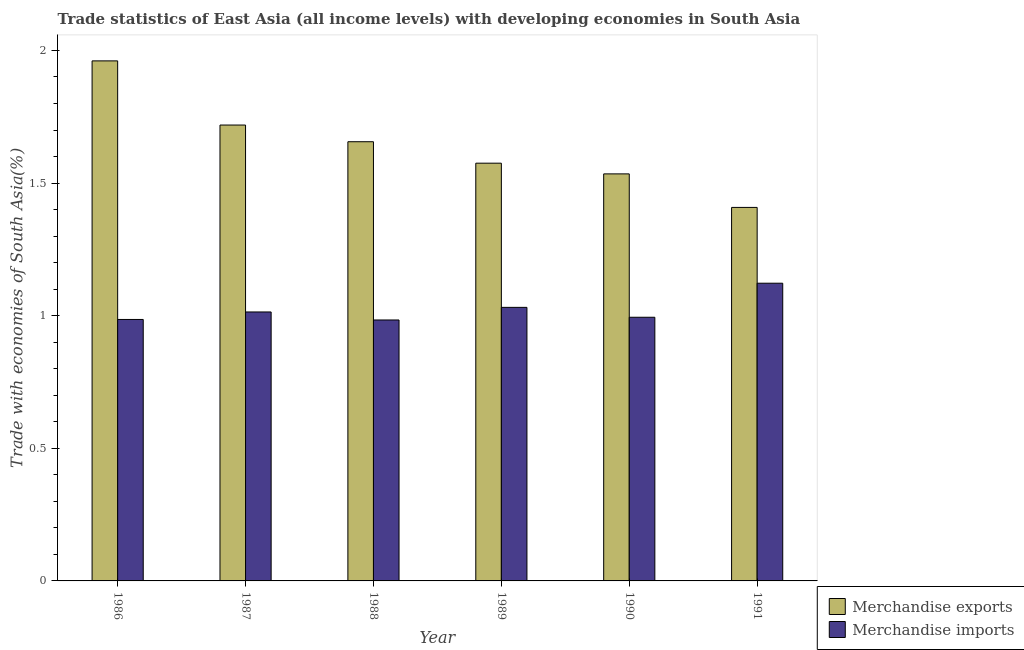How many different coloured bars are there?
Your response must be concise. 2. How many bars are there on the 2nd tick from the left?
Offer a terse response. 2. In how many cases, is the number of bars for a given year not equal to the number of legend labels?
Make the answer very short. 0. What is the merchandise imports in 1988?
Provide a short and direct response. 0.98. Across all years, what is the maximum merchandise imports?
Your answer should be compact. 1.12. Across all years, what is the minimum merchandise exports?
Offer a terse response. 1.41. In which year was the merchandise imports maximum?
Make the answer very short. 1991. What is the total merchandise exports in the graph?
Keep it short and to the point. 9.85. What is the difference between the merchandise exports in 1989 and that in 1990?
Provide a succinct answer. 0.04. What is the difference between the merchandise imports in 1988 and the merchandise exports in 1987?
Ensure brevity in your answer.  -0.03. What is the average merchandise exports per year?
Your answer should be compact. 1.64. In the year 1988, what is the difference between the merchandise imports and merchandise exports?
Your answer should be compact. 0. What is the ratio of the merchandise exports in 1986 to that in 1987?
Offer a terse response. 1.14. Is the merchandise imports in 1990 less than that in 1991?
Keep it short and to the point. Yes. Is the difference between the merchandise exports in 1988 and 1989 greater than the difference between the merchandise imports in 1988 and 1989?
Offer a very short reply. No. What is the difference between the highest and the second highest merchandise imports?
Provide a short and direct response. 0.09. What is the difference between the highest and the lowest merchandise imports?
Ensure brevity in your answer.  0.14. In how many years, is the merchandise exports greater than the average merchandise exports taken over all years?
Your answer should be compact. 3. Is the sum of the merchandise imports in 1989 and 1991 greater than the maximum merchandise exports across all years?
Offer a terse response. Yes. What does the 2nd bar from the left in 1989 represents?
Make the answer very short. Merchandise imports. How many bars are there?
Give a very brief answer. 12. How many years are there in the graph?
Your answer should be very brief. 6. Are the values on the major ticks of Y-axis written in scientific E-notation?
Make the answer very short. No. How many legend labels are there?
Offer a very short reply. 2. How are the legend labels stacked?
Ensure brevity in your answer.  Vertical. What is the title of the graph?
Make the answer very short. Trade statistics of East Asia (all income levels) with developing economies in South Asia. What is the label or title of the Y-axis?
Your answer should be compact. Trade with economies of South Asia(%). What is the Trade with economies of South Asia(%) in Merchandise exports in 1986?
Provide a short and direct response. 1.96. What is the Trade with economies of South Asia(%) of Merchandise imports in 1986?
Keep it short and to the point. 0.99. What is the Trade with economies of South Asia(%) of Merchandise exports in 1987?
Give a very brief answer. 1.72. What is the Trade with economies of South Asia(%) of Merchandise imports in 1987?
Your answer should be compact. 1.01. What is the Trade with economies of South Asia(%) of Merchandise exports in 1988?
Your answer should be very brief. 1.66. What is the Trade with economies of South Asia(%) of Merchandise imports in 1988?
Your answer should be very brief. 0.98. What is the Trade with economies of South Asia(%) in Merchandise exports in 1989?
Provide a short and direct response. 1.57. What is the Trade with economies of South Asia(%) in Merchandise imports in 1989?
Give a very brief answer. 1.03. What is the Trade with economies of South Asia(%) of Merchandise exports in 1990?
Offer a very short reply. 1.53. What is the Trade with economies of South Asia(%) in Merchandise imports in 1990?
Your answer should be very brief. 0.99. What is the Trade with economies of South Asia(%) in Merchandise exports in 1991?
Offer a terse response. 1.41. What is the Trade with economies of South Asia(%) in Merchandise imports in 1991?
Keep it short and to the point. 1.12. Across all years, what is the maximum Trade with economies of South Asia(%) of Merchandise exports?
Offer a terse response. 1.96. Across all years, what is the maximum Trade with economies of South Asia(%) of Merchandise imports?
Offer a very short reply. 1.12. Across all years, what is the minimum Trade with economies of South Asia(%) of Merchandise exports?
Keep it short and to the point. 1.41. Across all years, what is the minimum Trade with economies of South Asia(%) in Merchandise imports?
Make the answer very short. 0.98. What is the total Trade with economies of South Asia(%) of Merchandise exports in the graph?
Ensure brevity in your answer.  9.85. What is the total Trade with economies of South Asia(%) in Merchandise imports in the graph?
Your answer should be compact. 6.13. What is the difference between the Trade with economies of South Asia(%) of Merchandise exports in 1986 and that in 1987?
Your answer should be compact. 0.24. What is the difference between the Trade with economies of South Asia(%) of Merchandise imports in 1986 and that in 1987?
Offer a terse response. -0.03. What is the difference between the Trade with economies of South Asia(%) in Merchandise exports in 1986 and that in 1988?
Make the answer very short. 0.3. What is the difference between the Trade with economies of South Asia(%) of Merchandise imports in 1986 and that in 1988?
Your answer should be compact. 0. What is the difference between the Trade with economies of South Asia(%) of Merchandise exports in 1986 and that in 1989?
Ensure brevity in your answer.  0.39. What is the difference between the Trade with economies of South Asia(%) of Merchandise imports in 1986 and that in 1989?
Provide a succinct answer. -0.05. What is the difference between the Trade with economies of South Asia(%) of Merchandise exports in 1986 and that in 1990?
Offer a very short reply. 0.43. What is the difference between the Trade with economies of South Asia(%) in Merchandise imports in 1986 and that in 1990?
Your response must be concise. -0.01. What is the difference between the Trade with economies of South Asia(%) of Merchandise exports in 1986 and that in 1991?
Provide a short and direct response. 0.55. What is the difference between the Trade with economies of South Asia(%) in Merchandise imports in 1986 and that in 1991?
Offer a very short reply. -0.14. What is the difference between the Trade with economies of South Asia(%) of Merchandise exports in 1987 and that in 1988?
Offer a very short reply. 0.06. What is the difference between the Trade with economies of South Asia(%) in Merchandise imports in 1987 and that in 1988?
Make the answer very short. 0.03. What is the difference between the Trade with economies of South Asia(%) of Merchandise exports in 1987 and that in 1989?
Your response must be concise. 0.14. What is the difference between the Trade with economies of South Asia(%) of Merchandise imports in 1987 and that in 1989?
Your answer should be very brief. -0.02. What is the difference between the Trade with economies of South Asia(%) of Merchandise exports in 1987 and that in 1990?
Provide a short and direct response. 0.18. What is the difference between the Trade with economies of South Asia(%) of Merchandise exports in 1987 and that in 1991?
Your answer should be compact. 0.31. What is the difference between the Trade with economies of South Asia(%) of Merchandise imports in 1987 and that in 1991?
Give a very brief answer. -0.11. What is the difference between the Trade with economies of South Asia(%) in Merchandise exports in 1988 and that in 1989?
Offer a terse response. 0.08. What is the difference between the Trade with economies of South Asia(%) in Merchandise imports in 1988 and that in 1989?
Make the answer very short. -0.05. What is the difference between the Trade with economies of South Asia(%) of Merchandise exports in 1988 and that in 1990?
Your answer should be compact. 0.12. What is the difference between the Trade with economies of South Asia(%) of Merchandise imports in 1988 and that in 1990?
Your response must be concise. -0.01. What is the difference between the Trade with economies of South Asia(%) in Merchandise exports in 1988 and that in 1991?
Provide a succinct answer. 0.25. What is the difference between the Trade with economies of South Asia(%) of Merchandise imports in 1988 and that in 1991?
Provide a short and direct response. -0.14. What is the difference between the Trade with economies of South Asia(%) in Merchandise exports in 1989 and that in 1990?
Give a very brief answer. 0.04. What is the difference between the Trade with economies of South Asia(%) of Merchandise imports in 1989 and that in 1990?
Your answer should be compact. 0.04. What is the difference between the Trade with economies of South Asia(%) of Merchandise exports in 1989 and that in 1991?
Make the answer very short. 0.17. What is the difference between the Trade with economies of South Asia(%) in Merchandise imports in 1989 and that in 1991?
Make the answer very short. -0.09. What is the difference between the Trade with economies of South Asia(%) in Merchandise exports in 1990 and that in 1991?
Your response must be concise. 0.13. What is the difference between the Trade with economies of South Asia(%) in Merchandise imports in 1990 and that in 1991?
Keep it short and to the point. -0.13. What is the difference between the Trade with economies of South Asia(%) in Merchandise exports in 1986 and the Trade with economies of South Asia(%) in Merchandise imports in 1987?
Make the answer very short. 0.95. What is the difference between the Trade with economies of South Asia(%) of Merchandise exports in 1986 and the Trade with economies of South Asia(%) of Merchandise imports in 1988?
Your answer should be very brief. 0.98. What is the difference between the Trade with economies of South Asia(%) in Merchandise exports in 1986 and the Trade with economies of South Asia(%) in Merchandise imports in 1989?
Provide a succinct answer. 0.93. What is the difference between the Trade with economies of South Asia(%) of Merchandise exports in 1986 and the Trade with economies of South Asia(%) of Merchandise imports in 1990?
Give a very brief answer. 0.97. What is the difference between the Trade with economies of South Asia(%) of Merchandise exports in 1986 and the Trade with economies of South Asia(%) of Merchandise imports in 1991?
Offer a terse response. 0.84. What is the difference between the Trade with economies of South Asia(%) of Merchandise exports in 1987 and the Trade with economies of South Asia(%) of Merchandise imports in 1988?
Give a very brief answer. 0.73. What is the difference between the Trade with economies of South Asia(%) of Merchandise exports in 1987 and the Trade with economies of South Asia(%) of Merchandise imports in 1989?
Keep it short and to the point. 0.69. What is the difference between the Trade with economies of South Asia(%) in Merchandise exports in 1987 and the Trade with economies of South Asia(%) in Merchandise imports in 1990?
Provide a short and direct response. 0.72. What is the difference between the Trade with economies of South Asia(%) in Merchandise exports in 1987 and the Trade with economies of South Asia(%) in Merchandise imports in 1991?
Your answer should be compact. 0.6. What is the difference between the Trade with economies of South Asia(%) of Merchandise exports in 1988 and the Trade with economies of South Asia(%) of Merchandise imports in 1989?
Ensure brevity in your answer.  0.62. What is the difference between the Trade with economies of South Asia(%) in Merchandise exports in 1988 and the Trade with economies of South Asia(%) in Merchandise imports in 1990?
Ensure brevity in your answer.  0.66. What is the difference between the Trade with economies of South Asia(%) of Merchandise exports in 1988 and the Trade with economies of South Asia(%) of Merchandise imports in 1991?
Your answer should be very brief. 0.53. What is the difference between the Trade with economies of South Asia(%) in Merchandise exports in 1989 and the Trade with economies of South Asia(%) in Merchandise imports in 1990?
Your answer should be very brief. 0.58. What is the difference between the Trade with economies of South Asia(%) of Merchandise exports in 1989 and the Trade with economies of South Asia(%) of Merchandise imports in 1991?
Provide a short and direct response. 0.45. What is the difference between the Trade with economies of South Asia(%) in Merchandise exports in 1990 and the Trade with economies of South Asia(%) in Merchandise imports in 1991?
Give a very brief answer. 0.41. What is the average Trade with economies of South Asia(%) in Merchandise exports per year?
Offer a terse response. 1.64. What is the average Trade with economies of South Asia(%) of Merchandise imports per year?
Provide a succinct answer. 1.02. In the year 1986, what is the difference between the Trade with economies of South Asia(%) in Merchandise exports and Trade with economies of South Asia(%) in Merchandise imports?
Your response must be concise. 0.97. In the year 1987, what is the difference between the Trade with economies of South Asia(%) of Merchandise exports and Trade with economies of South Asia(%) of Merchandise imports?
Your response must be concise. 0.7. In the year 1988, what is the difference between the Trade with economies of South Asia(%) in Merchandise exports and Trade with economies of South Asia(%) in Merchandise imports?
Your answer should be compact. 0.67. In the year 1989, what is the difference between the Trade with economies of South Asia(%) of Merchandise exports and Trade with economies of South Asia(%) of Merchandise imports?
Ensure brevity in your answer.  0.54. In the year 1990, what is the difference between the Trade with economies of South Asia(%) in Merchandise exports and Trade with economies of South Asia(%) in Merchandise imports?
Make the answer very short. 0.54. In the year 1991, what is the difference between the Trade with economies of South Asia(%) of Merchandise exports and Trade with economies of South Asia(%) of Merchandise imports?
Keep it short and to the point. 0.29. What is the ratio of the Trade with economies of South Asia(%) of Merchandise exports in 1986 to that in 1987?
Keep it short and to the point. 1.14. What is the ratio of the Trade with economies of South Asia(%) in Merchandise imports in 1986 to that in 1987?
Provide a short and direct response. 0.97. What is the ratio of the Trade with economies of South Asia(%) of Merchandise exports in 1986 to that in 1988?
Keep it short and to the point. 1.18. What is the ratio of the Trade with economies of South Asia(%) in Merchandise imports in 1986 to that in 1988?
Your answer should be compact. 1. What is the ratio of the Trade with economies of South Asia(%) of Merchandise exports in 1986 to that in 1989?
Provide a short and direct response. 1.24. What is the ratio of the Trade with economies of South Asia(%) in Merchandise imports in 1986 to that in 1989?
Ensure brevity in your answer.  0.96. What is the ratio of the Trade with economies of South Asia(%) in Merchandise exports in 1986 to that in 1990?
Provide a short and direct response. 1.28. What is the ratio of the Trade with economies of South Asia(%) in Merchandise imports in 1986 to that in 1990?
Your answer should be very brief. 0.99. What is the ratio of the Trade with economies of South Asia(%) in Merchandise exports in 1986 to that in 1991?
Give a very brief answer. 1.39. What is the ratio of the Trade with economies of South Asia(%) of Merchandise imports in 1986 to that in 1991?
Your response must be concise. 0.88. What is the ratio of the Trade with economies of South Asia(%) of Merchandise exports in 1987 to that in 1988?
Ensure brevity in your answer.  1.04. What is the ratio of the Trade with economies of South Asia(%) of Merchandise imports in 1987 to that in 1988?
Your response must be concise. 1.03. What is the ratio of the Trade with economies of South Asia(%) of Merchandise exports in 1987 to that in 1989?
Your response must be concise. 1.09. What is the ratio of the Trade with economies of South Asia(%) in Merchandise imports in 1987 to that in 1989?
Keep it short and to the point. 0.98. What is the ratio of the Trade with economies of South Asia(%) of Merchandise exports in 1987 to that in 1990?
Provide a succinct answer. 1.12. What is the ratio of the Trade with economies of South Asia(%) of Merchandise imports in 1987 to that in 1990?
Keep it short and to the point. 1.02. What is the ratio of the Trade with economies of South Asia(%) of Merchandise exports in 1987 to that in 1991?
Provide a short and direct response. 1.22. What is the ratio of the Trade with economies of South Asia(%) of Merchandise imports in 1987 to that in 1991?
Provide a succinct answer. 0.9. What is the ratio of the Trade with economies of South Asia(%) of Merchandise exports in 1988 to that in 1989?
Give a very brief answer. 1.05. What is the ratio of the Trade with economies of South Asia(%) of Merchandise imports in 1988 to that in 1989?
Offer a terse response. 0.95. What is the ratio of the Trade with economies of South Asia(%) of Merchandise exports in 1988 to that in 1990?
Your answer should be very brief. 1.08. What is the ratio of the Trade with economies of South Asia(%) of Merchandise exports in 1988 to that in 1991?
Ensure brevity in your answer.  1.18. What is the ratio of the Trade with economies of South Asia(%) in Merchandise imports in 1988 to that in 1991?
Your answer should be very brief. 0.88. What is the ratio of the Trade with economies of South Asia(%) of Merchandise exports in 1989 to that in 1990?
Offer a very short reply. 1.03. What is the ratio of the Trade with economies of South Asia(%) of Merchandise imports in 1989 to that in 1990?
Ensure brevity in your answer.  1.04. What is the ratio of the Trade with economies of South Asia(%) in Merchandise exports in 1989 to that in 1991?
Offer a very short reply. 1.12. What is the ratio of the Trade with economies of South Asia(%) in Merchandise imports in 1989 to that in 1991?
Your answer should be compact. 0.92. What is the ratio of the Trade with economies of South Asia(%) in Merchandise exports in 1990 to that in 1991?
Your answer should be very brief. 1.09. What is the ratio of the Trade with economies of South Asia(%) in Merchandise imports in 1990 to that in 1991?
Provide a succinct answer. 0.89. What is the difference between the highest and the second highest Trade with economies of South Asia(%) in Merchandise exports?
Make the answer very short. 0.24. What is the difference between the highest and the second highest Trade with economies of South Asia(%) in Merchandise imports?
Ensure brevity in your answer.  0.09. What is the difference between the highest and the lowest Trade with economies of South Asia(%) of Merchandise exports?
Offer a very short reply. 0.55. What is the difference between the highest and the lowest Trade with economies of South Asia(%) in Merchandise imports?
Provide a short and direct response. 0.14. 